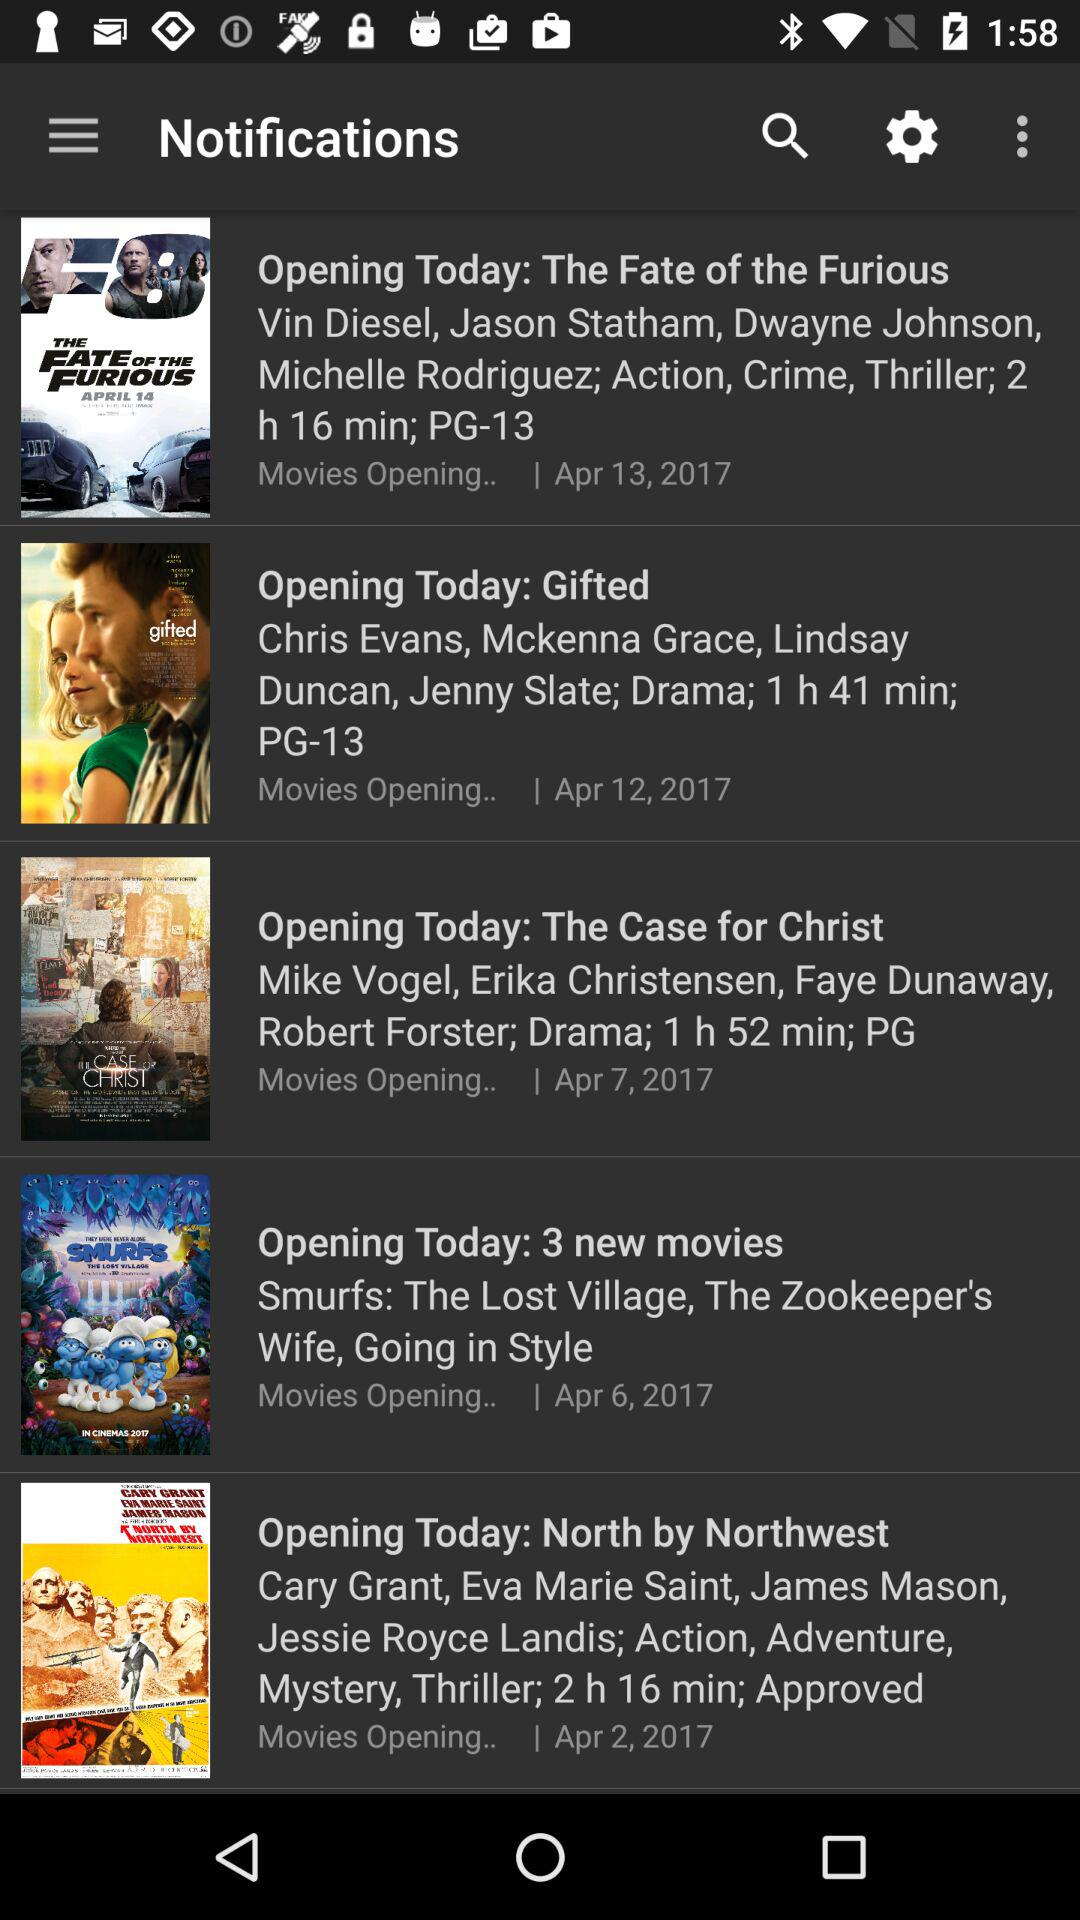What is the duration of the 3 new movies?
When the provided information is insufficient, respond with <no answer>. <no answer> 